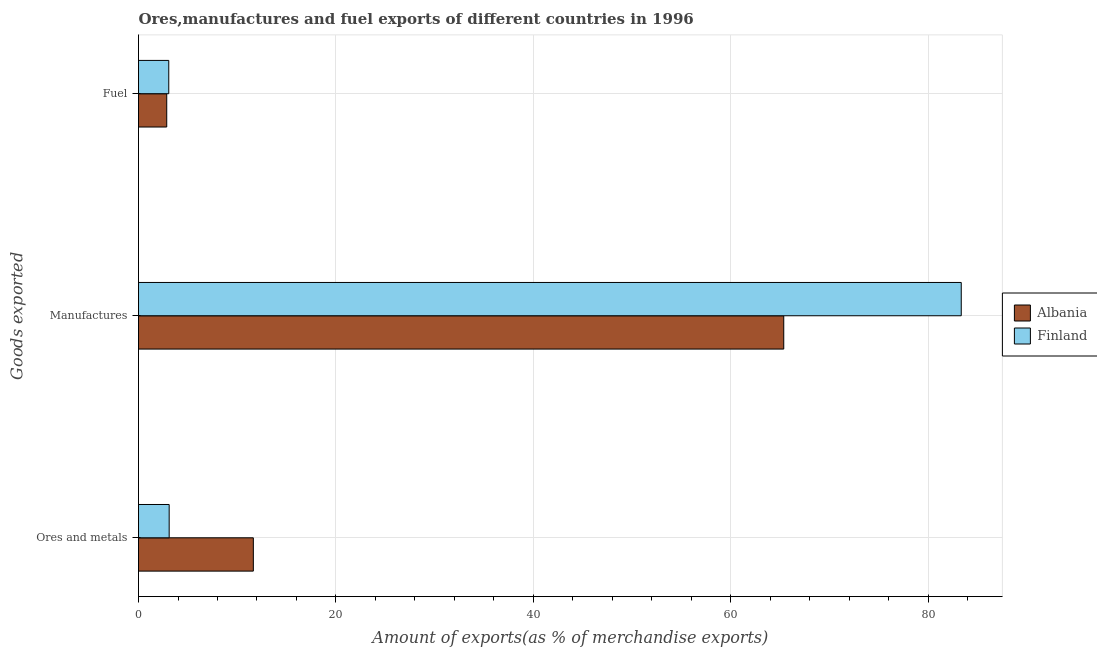How many different coloured bars are there?
Provide a succinct answer. 2. How many groups of bars are there?
Provide a short and direct response. 3. How many bars are there on the 2nd tick from the top?
Your answer should be compact. 2. What is the label of the 2nd group of bars from the top?
Your answer should be compact. Manufactures. What is the percentage of fuel exports in Albania?
Give a very brief answer. 2.86. Across all countries, what is the maximum percentage of manufactures exports?
Your answer should be compact. 83.35. Across all countries, what is the minimum percentage of ores and metals exports?
Provide a short and direct response. 3.11. What is the total percentage of ores and metals exports in the graph?
Offer a terse response. 14.74. What is the difference between the percentage of ores and metals exports in Albania and that in Finland?
Offer a terse response. 8.53. What is the difference between the percentage of fuel exports in Finland and the percentage of ores and metals exports in Albania?
Make the answer very short. -8.57. What is the average percentage of ores and metals exports per country?
Provide a short and direct response. 7.37. What is the difference between the percentage of ores and metals exports and percentage of manufactures exports in Albania?
Your response must be concise. -53.73. What is the ratio of the percentage of fuel exports in Finland to that in Albania?
Keep it short and to the point. 1.07. Is the percentage of manufactures exports in Albania less than that in Finland?
Your answer should be very brief. Yes. What is the difference between the highest and the second highest percentage of fuel exports?
Provide a short and direct response. 0.21. What is the difference between the highest and the lowest percentage of ores and metals exports?
Give a very brief answer. 8.53. What does the 2nd bar from the top in Fuel represents?
Provide a short and direct response. Albania. What does the 2nd bar from the bottom in Fuel represents?
Ensure brevity in your answer.  Finland. Is it the case that in every country, the sum of the percentage of ores and metals exports and percentage of manufactures exports is greater than the percentage of fuel exports?
Offer a terse response. Yes. Are all the bars in the graph horizontal?
Your answer should be very brief. Yes. What is the title of the graph?
Make the answer very short. Ores,manufactures and fuel exports of different countries in 1996. Does "Guinea-Bissau" appear as one of the legend labels in the graph?
Your response must be concise. No. What is the label or title of the X-axis?
Your response must be concise. Amount of exports(as % of merchandise exports). What is the label or title of the Y-axis?
Provide a succinct answer. Goods exported. What is the Amount of exports(as % of merchandise exports) in Albania in Ores and metals?
Your answer should be very brief. 11.63. What is the Amount of exports(as % of merchandise exports) of Finland in Ores and metals?
Provide a succinct answer. 3.11. What is the Amount of exports(as % of merchandise exports) of Albania in Manufactures?
Make the answer very short. 65.37. What is the Amount of exports(as % of merchandise exports) of Finland in Manufactures?
Provide a succinct answer. 83.35. What is the Amount of exports(as % of merchandise exports) of Albania in Fuel?
Your response must be concise. 2.86. What is the Amount of exports(as % of merchandise exports) in Finland in Fuel?
Offer a very short reply. 3.06. Across all Goods exported, what is the maximum Amount of exports(as % of merchandise exports) in Albania?
Your answer should be very brief. 65.37. Across all Goods exported, what is the maximum Amount of exports(as % of merchandise exports) in Finland?
Make the answer very short. 83.35. Across all Goods exported, what is the minimum Amount of exports(as % of merchandise exports) in Albania?
Offer a very short reply. 2.86. Across all Goods exported, what is the minimum Amount of exports(as % of merchandise exports) of Finland?
Give a very brief answer. 3.06. What is the total Amount of exports(as % of merchandise exports) in Albania in the graph?
Your answer should be very brief. 79.86. What is the total Amount of exports(as % of merchandise exports) of Finland in the graph?
Your response must be concise. 89.52. What is the difference between the Amount of exports(as % of merchandise exports) in Albania in Ores and metals and that in Manufactures?
Provide a short and direct response. -53.73. What is the difference between the Amount of exports(as % of merchandise exports) of Finland in Ores and metals and that in Manufactures?
Give a very brief answer. -80.24. What is the difference between the Amount of exports(as % of merchandise exports) of Albania in Ores and metals and that in Fuel?
Give a very brief answer. 8.77. What is the difference between the Amount of exports(as % of merchandise exports) of Finland in Ores and metals and that in Fuel?
Offer a terse response. 0.04. What is the difference between the Amount of exports(as % of merchandise exports) in Albania in Manufactures and that in Fuel?
Provide a short and direct response. 62.51. What is the difference between the Amount of exports(as % of merchandise exports) of Finland in Manufactures and that in Fuel?
Offer a very short reply. 80.28. What is the difference between the Amount of exports(as % of merchandise exports) in Albania in Ores and metals and the Amount of exports(as % of merchandise exports) in Finland in Manufactures?
Provide a short and direct response. -71.72. What is the difference between the Amount of exports(as % of merchandise exports) of Albania in Ores and metals and the Amount of exports(as % of merchandise exports) of Finland in Fuel?
Provide a succinct answer. 8.57. What is the difference between the Amount of exports(as % of merchandise exports) of Albania in Manufactures and the Amount of exports(as % of merchandise exports) of Finland in Fuel?
Give a very brief answer. 62.3. What is the average Amount of exports(as % of merchandise exports) in Albania per Goods exported?
Your answer should be compact. 26.62. What is the average Amount of exports(as % of merchandise exports) in Finland per Goods exported?
Provide a succinct answer. 29.84. What is the difference between the Amount of exports(as % of merchandise exports) in Albania and Amount of exports(as % of merchandise exports) in Finland in Ores and metals?
Your response must be concise. 8.53. What is the difference between the Amount of exports(as % of merchandise exports) in Albania and Amount of exports(as % of merchandise exports) in Finland in Manufactures?
Your response must be concise. -17.98. What is the difference between the Amount of exports(as % of merchandise exports) in Albania and Amount of exports(as % of merchandise exports) in Finland in Fuel?
Your answer should be very brief. -0.21. What is the ratio of the Amount of exports(as % of merchandise exports) of Albania in Ores and metals to that in Manufactures?
Offer a very short reply. 0.18. What is the ratio of the Amount of exports(as % of merchandise exports) of Finland in Ores and metals to that in Manufactures?
Your response must be concise. 0.04. What is the ratio of the Amount of exports(as % of merchandise exports) of Albania in Ores and metals to that in Fuel?
Your response must be concise. 4.07. What is the ratio of the Amount of exports(as % of merchandise exports) in Finland in Ores and metals to that in Fuel?
Make the answer very short. 1.01. What is the ratio of the Amount of exports(as % of merchandise exports) of Albania in Manufactures to that in Fuel?
Keep it short and to the point. 22.86. What is the ratio of the Amount of exports(as % of merchandise exports) in Finland in Manufactures to that in Fuel?
Provide a short and direct response. 27.2. What is the difference between the highest and the second highest Amount of exports(as % of merchandise exports) of Albania?
Your response must be concise. 53.73. What is the difference between the highest and the second highest Amount of exports(as % of merchandise exports) of Finland?
Ensure brevity in your answer.  80.24. What is the difference between the highest and the lowest Amount of exports(as % of merchandise exports) of Albania?
Your answer should be compact. 62.51. What is the difference between the highest and the lowest Amount of exports(as % of merchandise exports) of Finland?
Your answer should be compact. 80.28. 